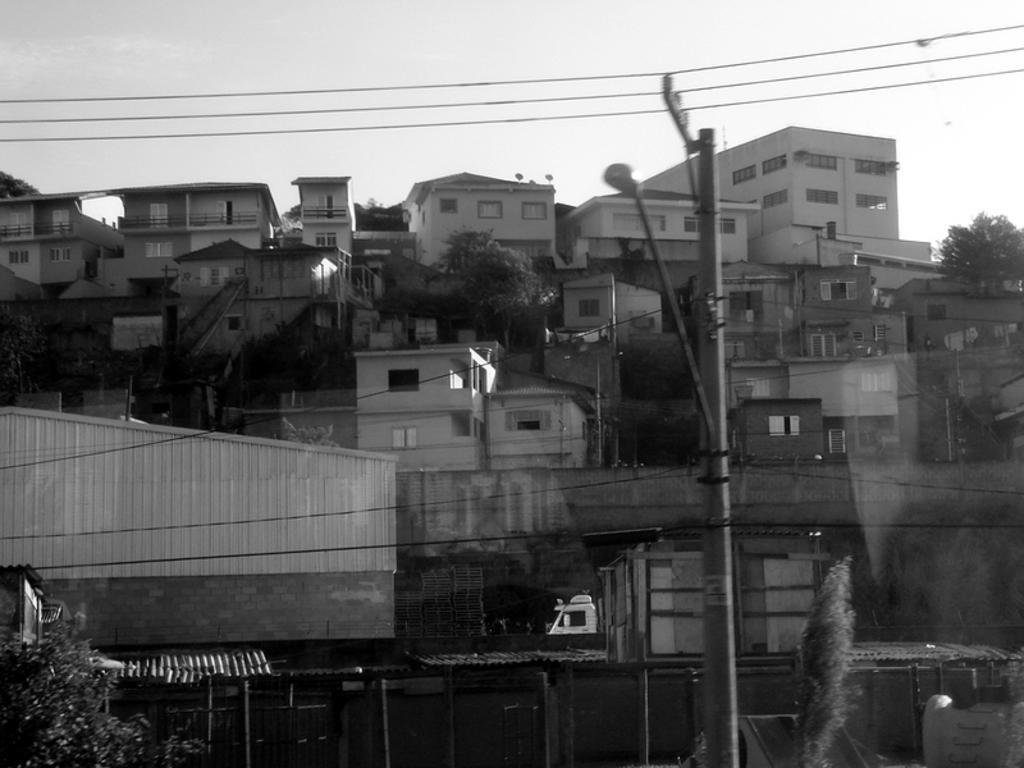Could you give a brief overview of what you see in this image? This is a black and white picture. In front of the picture, we see the electric poles and street lights. In the left bottom, we see a tree. There are trees and buildings in the background. At the top, we see the sky and the wires. 